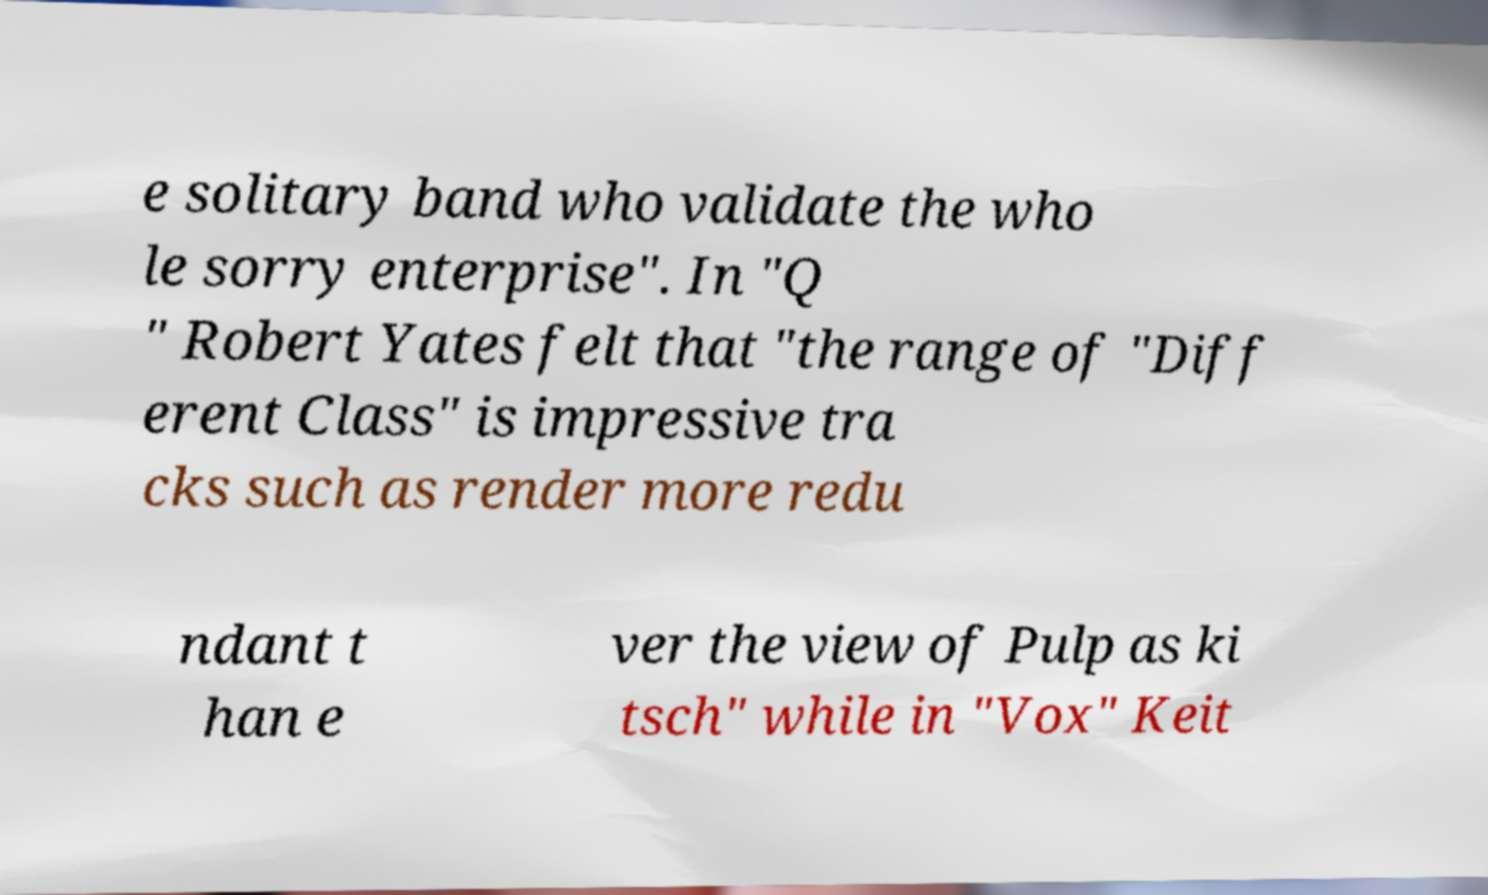There's text embedded in this image that I need extracted. Can you transcribe it verbatim? e solitary band who validate the who le sorry enterprise". In "Q " Robert Yates felt that "the range of "Diff erent Class" is impressive tra cks such as render more redu ndant t han e ver the view of Pulp as ki tsch" while in "Vox" Keit 